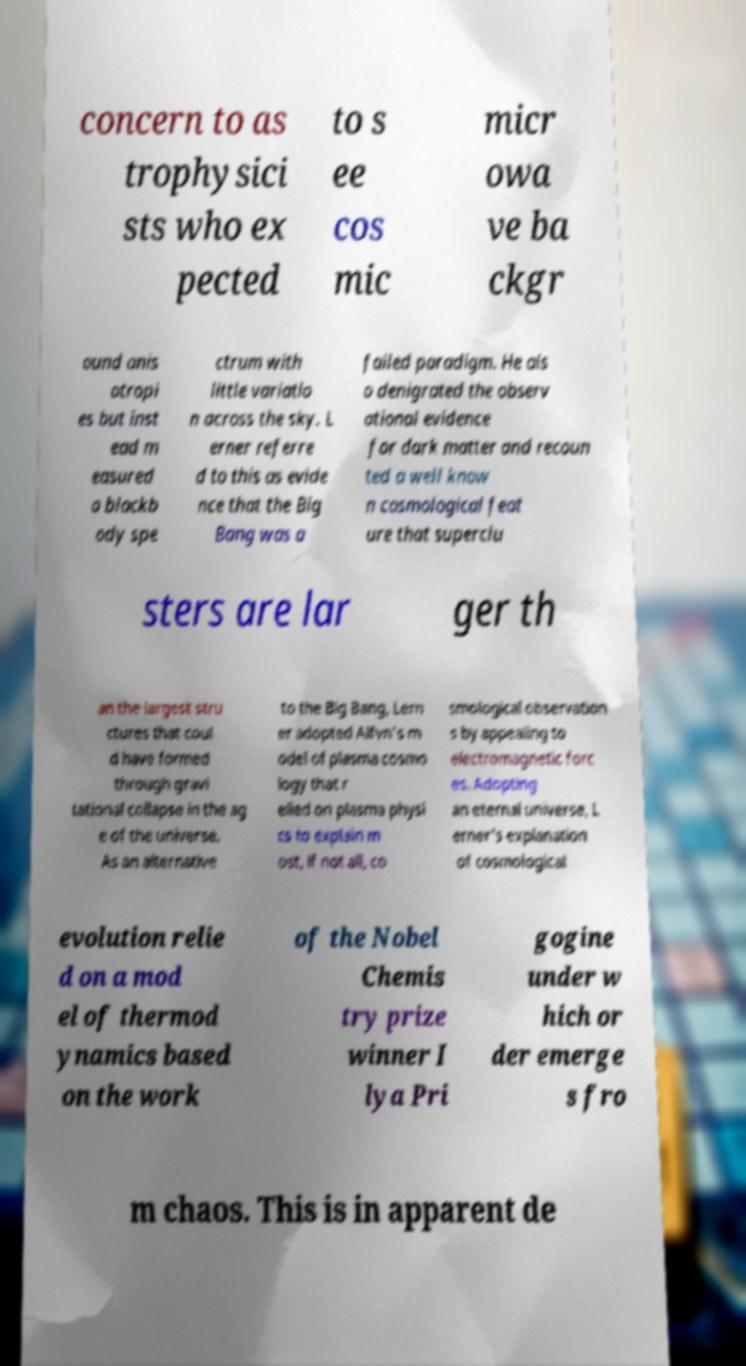What messages or text are displayed in this image? I need them in a readable, typed format. concern to as trophysici sts who ex pected to s ee cos mic micr owa ve ba ckgr ound anis otropi es but inst ead m easured a blackb ody spe ctrum with little variatio n across the sky. L erner referre d to this as evide nce that the Big Bang was a failed paradigm. He als o denigrated the observ ational evidence for dark matter and recoun ted a well know n cosmological feat ure that superclu sters are lar ger th an the largest stru ctures that coul d have formed through gravi tational collapse in the ag e of the universe. As an alternative to the Big Bang, Lern er adopted Alfvn's m odel of plasma cosmo logy that r elied on plasma physi cs to explain m ost, if not all, co smological observation s by appealing to electromagnetic forc es. Adopting an eternal universe, L erner's explanation of cosmological evolution relie d on a mod el of thermod ynamics based on the work of the Nobel Chemis try prize winner I lya Pri gogine under w hich or der emerge s fro m chaos. This is in apparent de 